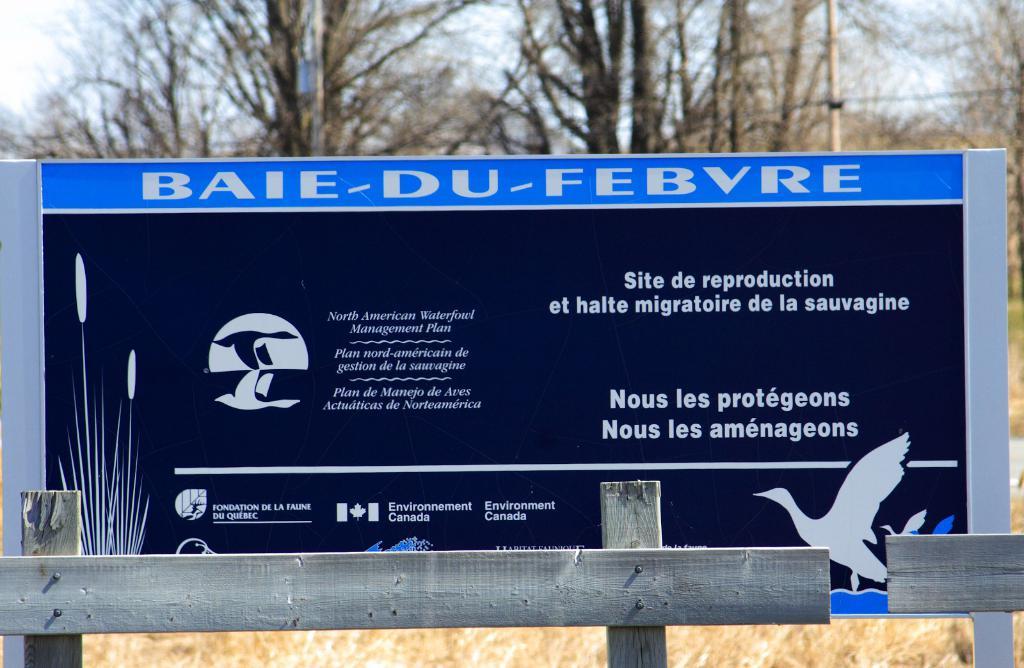What is the lowest sentence on the right?
Keep it short and to the point. Nous les amenageons. 